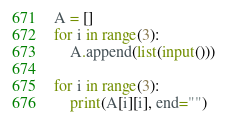<code> <loc_0><loc_0><loc_500><loc_500><_Python_>A = []
for i in range(3):
    A.append(list(input()))

for i in range(3):
    print(A[i][i], end="")</code> 